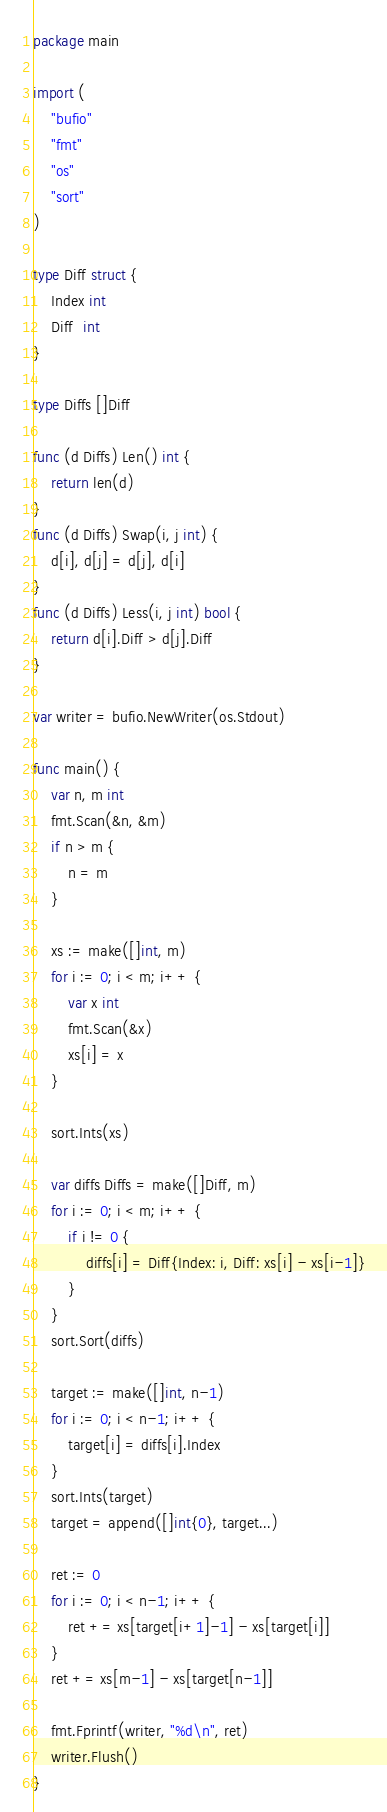Convert code to text. <code><loc_0><loc_0><loc_500><loc_500><_Go_>package main

import (
	"bufio"
	"fmt"
	"os"
	"sort"
)

type Diff struct {
	Index int
	Diff  int
}

type Diffs []Diff

func (d Diffs) Len() int {
	return len(d)
}
func (d Diffs) Swap(i, j int) {
	d[i], d[j] = d[j], d[i]
}
func (d Diffs) Less(i, j int) bool {
	return d[i].Diff > d[j].Diff
}

var writer = bufio.NewWriter(os.Stdout)

func main() {
	var n, m int
	fmt.Scan(&n, &m)
	if n > m {
		n = m
	}

	xs := make([]int, m)
	for i := 0; i < m; i++ {
		var x int
		fmt.Scan(&x)
		xs[i] = x
	}

	sort.Ints(xs)

	var diffs Diffs = make([]Diff, m)
	for i := 0; i < m; i++ {
		if i != 0 {
			diffs[i] = Diff{Index: i, Diff: xs[i] - xs[i-1]}
		}
	}
	sort.Sort(diffs)

	target := make([]int, n-1)
	for i := 0; i < n-1; i++ {
		target[i] = diffs[i].Index
	}
	sort.Ints(target)
	target = append([]int{0}, target...)

	ret := 0
	for i := 0; i < n-1; i++ {
		ret += xs[target[i+1]-1] - xs[target[i]]
	}
	ret += xs[m-1] - xs[target[n-1]]

	fmt.Fprintf(writer, "%d\n", ret)
	writer.Flush()
}
</code> 